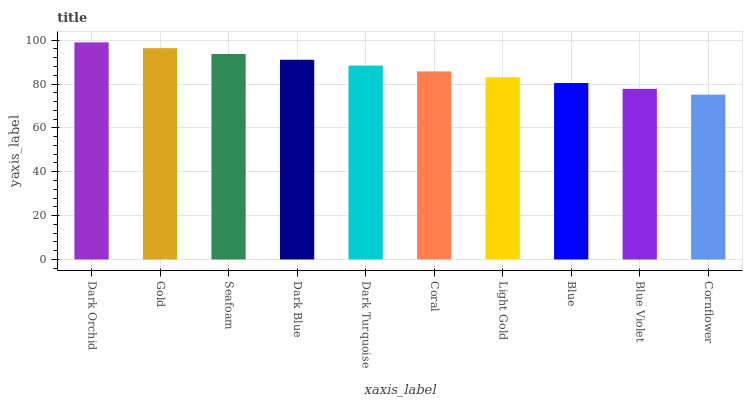Is Cornflower the minimum?
Answer yes or no. Yes. Is Dark Orchid the maximum?
Answer yes or no. Yes. Is Gold the minimum?
Answer yes or no. No. Is Gold the maximum?
Answer yes or no. No. Is Dark Orchid greater than Gold?
Answer yes or no. Yes. Is Gold less than Dark Orchid?
Answer yes or no. Yes. Is Gold greater than Dark Orchid?
Answer yes or no. No. Is Dark Orchid less than Gold?
Answer yes or no. No. Is Dark Turquoise the high median?
Answer yes or no. Yes. Is Coral the low median?
Answer yes or no. Yes. Is Dark Blue the high median?
Answer yes or no. No. Is Dark Orchid the low median?
Answer yes or no. No. 